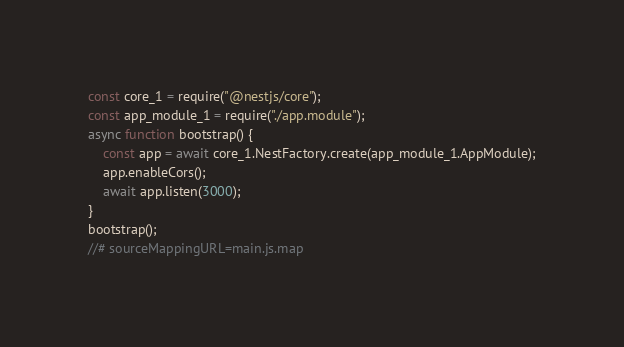Convert code to text. <code><loc_0><loc_0><loc_500><loc_500><_JavaScript_>const core_1 = require("@nestjs/core");
const app_module_1 = require("./app.module");
async function bootstrap() {
    const app = await core_1.NestFactory.create(app_module_1.AppModule);
    app.enableCors();
    await app.listen(3000);
}
bootstrap();
//# sourceMappingURL=main.js.map</code> 